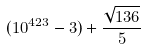Convert formula to latex. <formula><loc_0><loc_0><loc_500><loc_500>( 1 0 ^ { 4 2 3 } - 3 ) + \frac { \sqrt { 1 3 6 } } { 5 }</formula> 